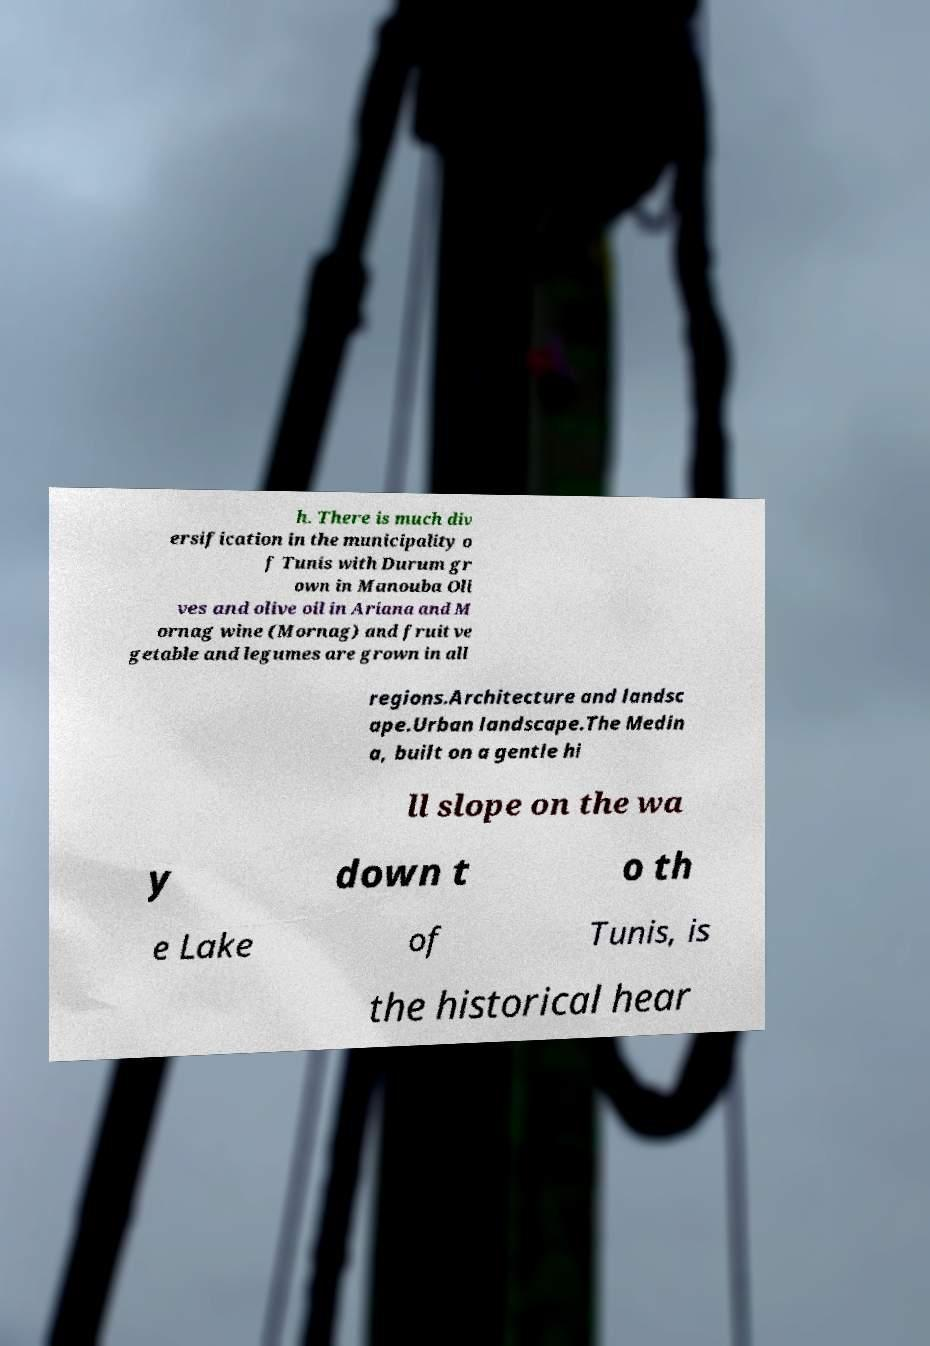Can you read and provide the text displayed in the image?This photo seems to have some interesting text. Can you extract and type it out for me? h. There is much div ersification in the municipality o f Tunis with Durum gr own in Manouba Oli ves and olive oil in Ariana and M ornag wine (Mornag) and fruit ve getable and legumes are grown in all regions.Architecture and landsc ape.Urban landscape.The Medin a, built on a gentle hi ll slope on the wa y down t o th e Lake of Tunis, is the historical hear 